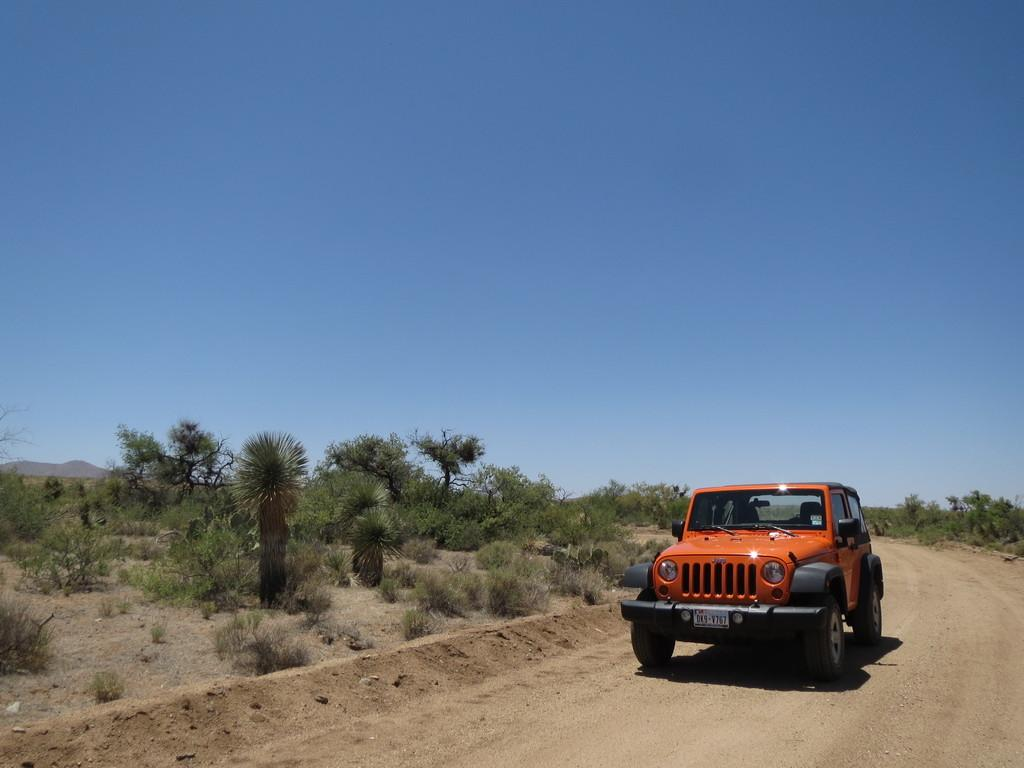What is the main feature of the image? There is a road in the image. What type of vehicle can be seen on the road? There is a black and orange car in the image. What type of vegetation is present in the image? There are green trees in the image. What can be seen in the distance in the image? There is a mountain visible in the background of the image, and the sky is also visible. What type of potato is being used in the competition in the image? There is no potato or competition present in the image. How much waste is visible in the image? There is no waste visible in the image. 